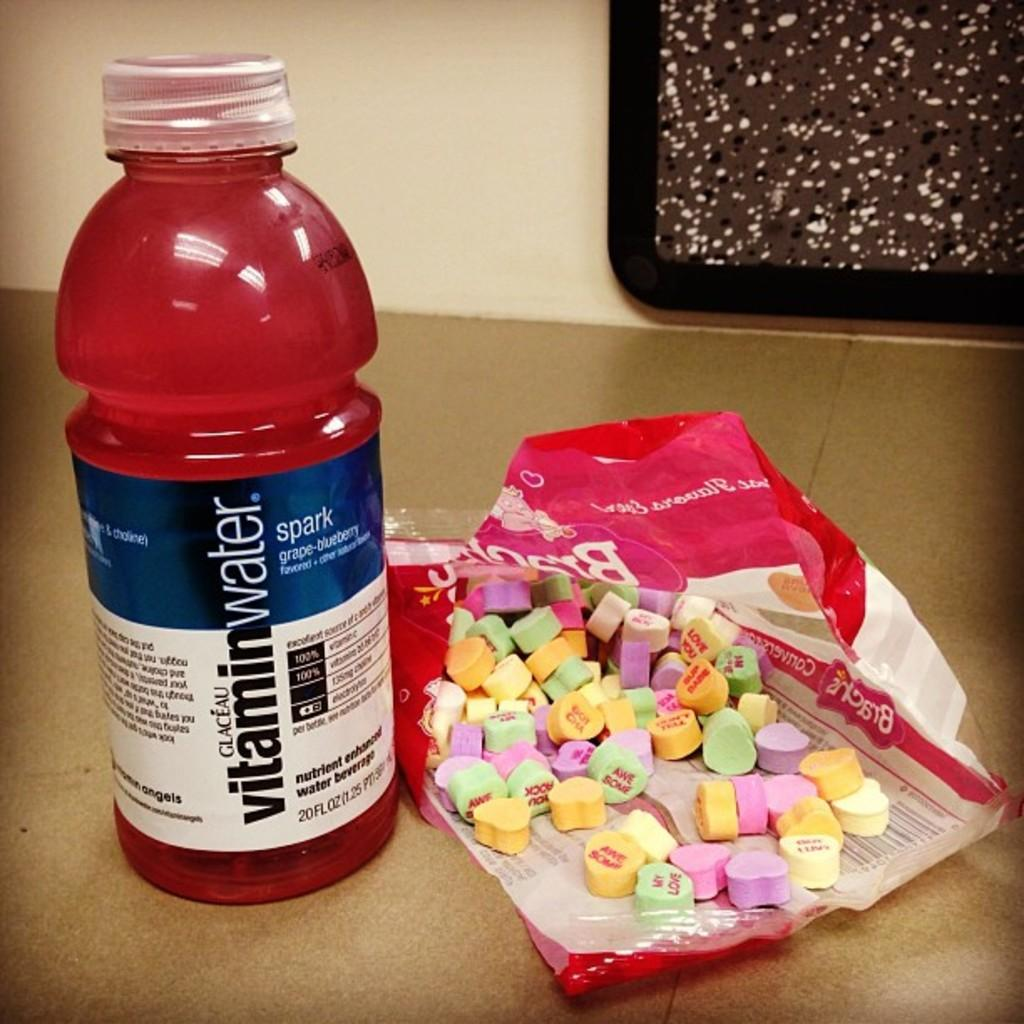<image>
Describe the image concisely. An opened bag of heart shaped candy with a bottle of grape-blueberry Vitamin Water, 